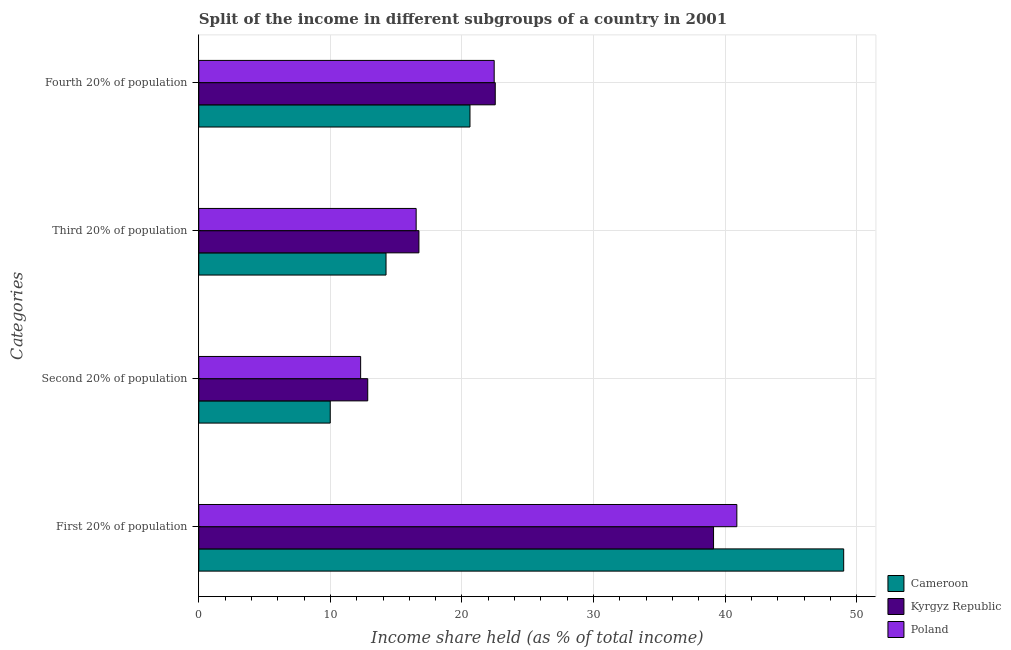Are the number of bars per tick equal to the number of legend labels?
Your answer should be very brief. Yes. How many bars are there on the 3rd tick from the bottom?
Offer a very short reply. 3. What is the label of the 4th group of bars from the top?
Your response must be concise. First 20% of population. What is the share of the income held by second 20% of the population in Kyrgyz Republic?
Keep it short and to the point. 12.84. Across all countries, what is the maximum share of the income held by second 20% of the population?
Provide a short and direct response. 12.84. Across all countries, what is the minimum share of the income held by first 20% of the population?
Ensure brevity in your answer.  39.12. In which country was the share of the income held by fourth 20% of the population maximum?
Provide a succinct answer. Kyrgyz Republic. In which country was the share of the income held by first 20% of the population minimum?
Provide a short and direct response. Kyrgyz Republic. What is the total share of the income held by third 20% of the population in the graph?
Offer a terse response. 47.48. What is the difference between the share of the income held by third 20% of the population in Kyrgyz Republic and that in Poland?
Make the answer very short. 0.21. What is the difference between the share of the income held by third 20% of the population in Poland and the share of the income held by fourth 20% of the population in Cameroon?
Your answer should be compact. -4.09. What is the average share of the income held by fourth 20% of the population per country?
Provide a short and direct response. 21.86. What is the difference between the share of the income held by first 20% of the population and share of the income held by fourth 20% of the population in Cameroon?
Offer a very short reply. 28.4. In how many countries, is the share of the income held by third 20% of the population greater than 32 %?
Your response must be concise. 0. What is the ratio of the share of the income held by first 20% of the population in Poland to that in Cameroon?
Your answer should be very brief. 0.83. Is the difference between the share of the income held by first 20% of the population in Kyrgyz Republic and Cameroon greater than the difference between the share of the income held by second 20% of the population in Kyrgyz Republic and Cameroon?
Offer a very short reply. No. What is the difference between the highest and the second highest share of the income held by third 20% of the population?
Offer a very short reply. 0.21. What is the difference between the highest and the lowest share of the income held by second 20% of the population?
Ensure brevity in your answer.  2.85. Is the sum of the share of the income held by fourth 20% of the population in Kyrgyz Republic and Poland greater than the maximum share of the income held by second 20% of the population across all countries?
Your answer should be very brief. Yes. How many bars are there?
Give a very brief answer. 12. Are all the bars in the graph horizontal?
Offer a very short reply. Yes. How many countries are there in the graph?
Keep it short and to the point. 3. What is the difference between two consecutive major ticks on the X-axis?
Provide a succinct answer. 10. Does the graph contain any zero values?
Offer a terse response. No. Does the graph contain grids?
Keep it short and to the point. Yes. How many legend labels are there?
Ensure brevity in your answer.  3. How are the legend labels stacked?
Offer a very short reply. Vertical. What is the title of the graph?
Your response must be concise. Split of the income in different subgroups of a country in 2001. What is the label or title of the X-axis?
Offer a terse response. Income share held (as % of total income). What is the label or title of the Y-axis?
Make the answer very short. Categories. What is the Income share held (as % of total income) in Cameroon in First 20% of population?
Keep it short and to the point. 49.01. What is the Income share held (as % of total income) in Kyrgyz Republic in First 20% of population?
Provide a succinct answer. 39.12. What is the Income share held (as % of total income) in Poland in First 20% of population?
Provide a short and direct response. 40.89. What is the Income share held (as % of total income) in Cameroon in Second 20% of population?
Give a very brief answer. 9.99. What is the Income share held (as % of total income) of Kyrgyz Republic in Second 20% of population?
Ensure brevity in your answer.  12.84. What is the Income share held (as % of total income) in Poland in Second 20% of population?
Your response must be concise. 12.3. What is the Income share held (as % of total income) in Cameroon in Third 20% of population?
Give a very brief answer. 14.23. What is the Income share held (as % of total income) in Kyrgyz Republic in Third 20% of population?
Give a very brief answer. 16.73. What is the Income share held (as % of total income) in Poland in Third 20% of population?
Provide a succinct answer. 16.52. What is the Income share held (as % of total income) of Cameroon in Fourth 20% of population?
Offer a terse response. 20.61. What is the Income share held (as % of total income) of Kyrgyz Republic in Fourth 20% of population?
Provide a short and direct response. 22.53. What is the Income share held (as % of total income) in Poland in Fourth 20% of population?
Provide a succinct answer. 22.45. Across all Categories, what is the maximum Income share held (as % of total income) of Cameroon?
Your response must be concise. 49.01. Across all Categories, what is the maximum Income share held (as % of total income) in Kyrgyz Republic?
Keep it short and to the point. 39.12. Across all Categories, what is the maximum Income share held (as % of total income) of Poland?
Ensure brevity in your answer.  40.89. Across all Categories, what is the minimum Income share held (as % of total income) in Cameroon?
Offer a very short reply. 9.99. Across all Categories, what is the minimum Income share held (as % of total income) of Kyrgyz Republic?
Offer a very short reply. 12.84. Across all Categories, what is the minimum Income share held (as % of total income) in Poland?
Ensure brevity in your answer.  12.3. What is the total Income share held (as % of total income) of Cameroon in the graph?
Provide a short and direct response. 93.84. What is the total Income share held (as % of total income) in Kyrgyz Republic in the graph?
Your response must be concise. 91.22. What is the total Income share held (as % of total income) in Poland in the graph?
Your answer should be compact. 92.16. What is the difference between the Income share held (as % of total income) of Cameroon in First 20% of population and that in Second 20% of population?
Your response must be concise. 39.02. What is the difference between the Income share held (as % of total income) in Kyrgyz Republic in First 20% of population and that in Second 20% of population?
Make the answer very short. 26.28. What is the difference between the Income share held (as % of total income) in Poland in First 20% of population and that in Second 20% of population?
Provide a succinct answer. 28.59. What is the difference between the Income share held (as % of total income) of Cameroon in First 20% of population and that in Third 20% of population?
Give a very brief answer. 34.78. What is the difference between the Income share held (as % of total income) of Kyrgyz Republic in First 20% of population and that in Third 20% of population?
Keep it short and to the point. 22.39. What is the difference between the Income share held (as % of total income) in Poland in First 20% of population and that in Third 20% of population?
Your answer should be compact. 24.37. What is the difference between the Income share held (as % of total income) in Cameroon in First 20% of population and that in Fourth 20% of population?
Your response must be concise. 28.4. What is the difference between the Income share held (as % of total income) of Kyrgyz Republic in First 20% of population and that in Fourth 20% of population?
Provide a succinct answer. 16.59. What is the difference between the Income share held (as % of total income) in Poland in First 20% of population and that in Fourth 20% of population?
Provide a short and direct response. 18.44. What is the difference between the Income share held (as % of total income) in Cameroon in Second 20% of population and that in Third 20% of population?
Provide a short and direct response. -4.24. What is the difference between the Income share held (as % of total income) in Kyrgyz Republic in Second 20% of population and that in Third 20% of population?
Give a very brief answer. -3.89. What is the difference between the Income share held (as % of total income) in Poland in Second 20% of population and that in Third 20% of population?
Ensure brevity in your answer.  -4.22. What is the difference between the Income share held (as % of total income) in Cameroon in Second 20% of population and that in Fourth 20% of population?
Keep it short and to the point. -10.62. What is the difference between the Income share held (as % of total income) of Kyrgyz Republic in Second 20% of population and that in Fourth 20% of population?
Give a very brief answer. -9.69. What is the difference between the Income share held (as % of total income) of Poland in Second 20% of population and that in Fourth 20% of population?
Your response must be concise. -10.15. What is the difference between the Income share held (as % of total income) in Cameroon in Third 20% of population and that in Fourth 20% of population?
Your answer should be very brief. -6.38. What is the difference between the Income share held (as % of total income) in Kyrgyz Republic in Third 20% of population and that in Fourth 20% of population?
Offer a terse response. -5.8. What is the difference between the Income share held (as % of total income) of Poland in Third 20% of population and that in Fourth 20% of population?
Give a very brief answer. -5.93. What is the difference between the Income share held (as % of total income) in Cameroon in First 20% of population and the Income share held (as % of total income) in Kyrgyz Republic in Second 20% of population?
Keep it short and to the point. 36.17. What is the difference between the Income share held (as % of total income) in Cameroon in First 20% of population and the Income share held (as % of total income) in Poland in Second 20% of population?
Give a very brief answer. 36.71. What is the difference between the Income share held (as % of total income) in Kyrgyz Republic in First 20% of population and the Income share held (as % of total income) in Poland in Second 20% of population?
Keep it short and to the point. 26.82. What is the difference between the Income share held (as % of total income) in Cameroon in First 20% of population and the Income share held (as % of total income) in Kyrgyz Republic in Third 20% of population?
Provide a succinct answer. 32.28. What is the difference between the Income share held (as % of total income) of Cameroon in First 20% of population and the Income share held (as % of total income) of Poland in Third 20% of population?
Ensure brevity in your answer.  32.49. What is the difference between the Income share held (as % of total income) in Kyrgyz Republic in First 20% of population and the Income share held (as % of total income) in Poland in Third 20% of population?
Your answer should be compact. 22.6. What is the difference between the Income share held (as % of total income) in Cameroon in First 20% of population and the Income share held (as % of total income) in Kyrgyz Republic in Fourth 20% of population?
Offer a very short reply. 26.48. What is the difference between the Income share held (as % of total income) of Cameroon in First 20% of population and the Income share held (as % of total income) of Poland in Fourth 20% of population?
Give a very brief answer. 26.56. What is the difference between the Income share held (as % of total income) in Kyrgyz Republic in First 20% of population and the Income share held (as % of total income) in Poland in Fourth 20% of population?
Provide a short and direct response. 16.67. What is the difference between the Income share held (as % of total income) in Cameroon in Second 20% of population and the Income share held (as % of total income) in Kyrgyz Republic in Third 20% of population?
Ensure brevity in your answer.  -6.74. What is the difference between the Income share held (as % of total income) of Cameroon in Second 20% of population and the Income share held (as % of total income) of Poland in Third 20% of population?
Provide a succinct answer. -6.53. What is the difference between the Income share held (as % of total income) in Kyrgyz Republic in Second 20% of population and the Income share held (as % of total income) in Poland in Third 20% of population?
Give a very brief answer. -3.68. What is the difference between the Income share held (as % of total income) in Cameroon in Second 20% of population and the Income share held (as % of total income) in Kyrgyz Republic in Fourth 20% of population?
Your answer should be compact. -12.54. What is the difference between the Income share held (as % of total income) of Cameroon in Second 20% of population and the Income share held (as % of total income) of Poland in Fourth 20% of population?
Offer a terse response. -12.46. What is the difference between the Income share held (as % of total income) in Kyrgyz Republic in Second 20% of population and the Income share held (as % of total income) in Poland in Fourth 20% of population?
Offer a terse response. -9.61. What is the difference between the Income share held (as % of total income) of Cameroon in Third 20% of population and the Income share held (as % of total income) of Poland in Fourth 20% of population?
Offer a terse response. -8.22. What is the difference between the Income share held (as % of total income) in Kyrgyz Republic in Third 20% of population and the Income share held (as % of total income) in Poland in Fourth 20% of population?
Your answer should be very brief. -5.72. What is the average Income share held (as % of total income) of Cameroon per Categories?
Offer a very short reply. 23.46. What is the average Income share held (as % of total income) of Kyrgyz Republic per Categories?
Offer a very short reply. 22.8. What is the average Income share held (as % of total income) of Poland per Categories?
Give a very brief answer. 23.04. What is the difference between the Income share held (as % of total income) in Cameroon and Income share held (as % of total income) in Kyrgyz Republic in First 20% of population?
Provide a succinct answer. 9.89. What is the difference between the Income share held (as % of total income) of Cameroon and Income share held (as % of total income) of Poland in First 20% of population?
Ensure brevity in your answer.  8.12. What is the difference between the Income share held (as % of total income) in Kyrgyz Republic and Income share held (as % of total income) in Poland in First 20% of population?
Keep it short and to the point. -1.77. What is the difference between the Income share held (as % of total income) in Cameroon and Income share held (as % of total income) in Kyrgyz Republic in Second 20% of population?
Your response must be concise. -2.85. What is the difference between the Income share held (as % of total income) of Cameroon and Income share held (as % of total income) of Poland in Second 20% of population?
Your answer should be compact. -2.31. What is the difference between the Income share held (as % of total income) of Kyrgyz Republic and Income share held (as % of total income) of Poland in Second 20% of population?
Give a very brief answer. 0.54. What is the difference between the Income share held (as % of total income) in Cameroon and Income share held (as % of total income) in Kyrgyz Republic in Third 20% of population?
Your answer should be compact. -2.5. What is the difference between the Income share held (as % of total income) in Cameroon and Income share held (as % of total income) in Poland in Third 20% of population?
Keep it short and to the point. -2.29. What is the difference between the Income share held (as % of total income) in Kyrgyz Republic and Income share held (as % of total income) in Poland in Third 20% of population?
Your answer should be compact. 0.21. What is the difference between the Income share held (as % of total income) in Cameroon and Income share held (as % of total income) in Kyrgyz Republic in Fourth 20% of population?
Provide a succinct answer. -1.92. What is the difference between the Income share held (as % of total income) of Cameroon and Income share held (as % of total income) of Poland in Fourth 20% of population?
Ensure brevity in your answer.  -1.84. What is the difference between the Income share held (as % of total income) in Kyrgyz Republic and Income share held (as % of total income) in Poland in Fourth 20% of population?
Keep it short and to the point. 0.08. What is the ratio of the Income share held (as % of total income) in Cameroon in First 20% of population to that in Second 20% of population?
Keep it short and to the point. 4.91. What is the ratio of the Income share held (as % of total income) in Kyrgyz Republic in First 20% of population to that in Second 20% of population?
Provide a succinct answer. 3.05. What is the ratio of the Income share held (as % of total income) in Poland in First 20% of population to that in Second 20% of population?
Ensure brevity in your answer.  3.32. What is the ratio of the Income share held (as % of total income) of Cameroon in First 20% of population to that in Third 20% of population?
Offer a very short reply. 3.44. What is the ratio of the Income share held (as % of total income) of Kyrgyz Republic in First 20% of population to that in Third 20% of population?
Offer a terse response. 2.34. What is the ratio of the Income share held (as % of total income) in Poland in First 20% of population to that in Third 20% of population?
Offer a terse response. 2.48. What is the ratio of the Income share held (as % of total income) in Cameroon in First 20% of population to that in Fourth 20% of population?
Offer a very short reply. 2.38. What is the ratio of the Income share held (as % of total income) in Kyrgyz Republic in First 20% of population to that in Fourth 20% of population?
Offer a very short reply. 1.74. What is the ratio of the Income share held (as % of total income) in Poland in First 20% of population to that in Fourth 20% of population?
Keep it short and to the point. 1.82. What is the ratio of the Income share held (as % of total income) of Cameroon in Second 20% of population to that in Third 20% of population?
Offer a very short reply. 0.7. What is the ratio of the Income share held (as % of total income) of Kyrgyz Republic in Second 20% of population to that in Third 20% of population?
Your answer should be compact. 0.77. What is the ratio of the Income share held (as % of total income) of Poland in Second 20% of population to that in Third 20% of population?
Provide a short and direct response. 0.74. What is the ratio of the Income share held (as % of total income) in Cameroon in Second 20% of population to that in Fourth 20% of population?
Keep it short and to the point. 0.48. What is the ratio of the Income share held (as % of total income) of Kyrgyz Republic in Second 20% of population to that in Fourth 20% of population?
Your answer should be compact. 0.57. What is the ratio of the Income share held (as % of total income) in Poland in Second 20% of population to that in Fourth 20% of population?
Ensure brevity in your answer.  0.55. What is the ratio of the Income share held (as % of total income) of Cameroon in Third 20% of population to that in Fourth 20% of population?
Make the answer very short. 0.69. What is the ratio of the Income share held (as % of total income) of Kyrgyz Republic in Third 20% of population to that in Fourth 20% of population?
Your answer should be compact. 0.74. What is the ratio of the Income share held (as % of total income) of Poland in Third 20% of population to that in Fourth 20% of population?
Offer a terse response. 0.74. What is the difference between the highest and the second highest Income share held (as % of total income) in Cameroon?
Offer a very short reply. 28.4. What is the difference between the highest and the second highest Income share held (as % of total income) of Kyrgyz Republic?
Provide a short and direct response. 16.59. What is the difference between the highest and the second highest Income share held (as % of total income) in Poland?
Offer a very short reply. 18.44. What is the difference between the highest and the lowest Income share held (as % of total income) in Cameroon?
Offer a very short reply. 39.02. What is the difference between the highest and the lowest Income share held (as % of total income) of Kyrgyz Republic?
Provide a short and direct response. 26.28. What is the difference between the highest and the lowest Income share held (as % of total income) of Poland?
Your response must be concise. 28.59. 